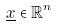<formula> <loc_0><loc_0><loc_500><loc_500>\underline { x } \in \mathbb { R } ^ { n }</formula> 